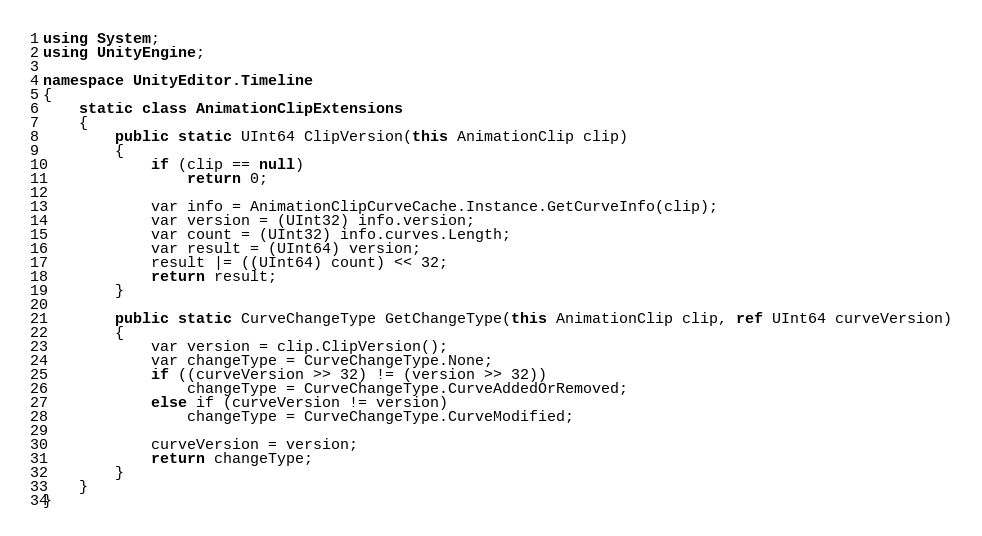Convert code to text. <code><loc_0><loc_0><loc_500><loc_500><_C#_>using System;
using UnityEngine;

namespace UnityEditor.Timeline
{
    static class AnimationClipExtensions
    {
        public static UInt64 ClipVersion(this AnimationClip clip)
        {
            if (clip == null)
                return 0;

            var info = AnimationClipCurveCache.Instance.GetCurveInfo(clip);
            var version = (UInt32) info.version;
            var count = (UInt32) info.curves.Length;
            var result = (UInt64) version;
            result |= ((UInt64) count) << 32;
            return result;
        }

        public static CurveChangeType GetChangeType(this AnimationClip clip, ref UInt64 curveVersion)
        {
            var version = clip.ClipVersion();
            var changeType = CurveChangeType.None;
            if ((curveVersion >> 32) != (version >> 32))
                changeType = CurveChangeType.CurveAddedOrRemoved;
            else if (curveVersion != version)
                changeType = CurveChangeType.CurveModified;

            curveVersion = version;
            return changeType;
        }
    }
}
</code> 